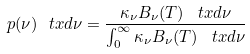Convert formula to latex. <formula><loc_0><loc_0><loc_500><loc_500>p ( \nu ) \ t x d \nu = \frac { \kappa _ { \nu } B _ { \nu } ( T ) \, \ t x d \nu } { \int _ { 0 } ^ { \infty } \kappa _ { \nu } B _ { \nu } ( T ) \, \ t x d \nu }</formula> 